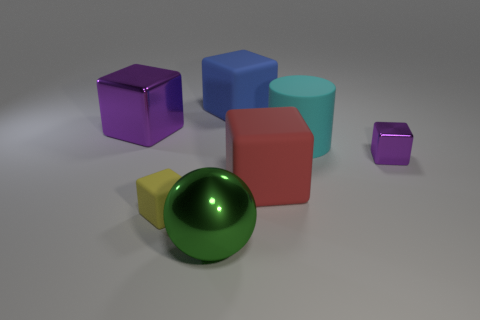Is there any other thing that is the same color as the tiny shiny cube?
Keep it short and to the point. Yes. What shape is the green thing?
Your answer should be compact. Sphere. Do the tiny shiny thing and the large shiny cube have the same color?
Your answer should be compact. Yes. There is a metal block that is the same size as the yellow rubber block; what color is it?
Your answer should be compact. Purple. What number of gray objects are matte blocks or big matte objects?
Provide a succinct answer. 0. Are there more rubber cubes than purple cubes?
Make the answer very short. Yes. There is a shiny thing that is behind the large cyan rubber cylinder; is it the same size as the blue rubber thing that is behind the green thing?
Provide a succinct answer. Yes. What color is the big block behind the purple metal object to the left of the rubber thing to the left of the blue rubber block?
Keep it short and to the point. Blue. Are there any cyan rubber objects of the same shape as the blue matte thing?
Offer a terse response. No. Is the number of big blue matte cubes to the left of the big red rubber thing greater than the number of tiny cyan shiny cubes?
Make the answer very short. Yes. 